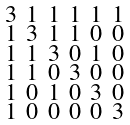<formula> <loc_0><loc_0><loc_500><loc_500>\begin{smallmatrix} 3 & 1 & 1 & 1 & 1 & 1 \\ 1 & 3 & 1 & 1 & 0 & 0 \\ 1 & 1 & 3 & 0 & 1 & 0 \\ 1 & 1 & 0 & 3 & 0 & 0 \\ 1 & 0 & 1 & 0 & 3 & 0 \\ 1 & 0 & 0 & 0 & 0 & 3 \end{smallmatrix}</formula> 